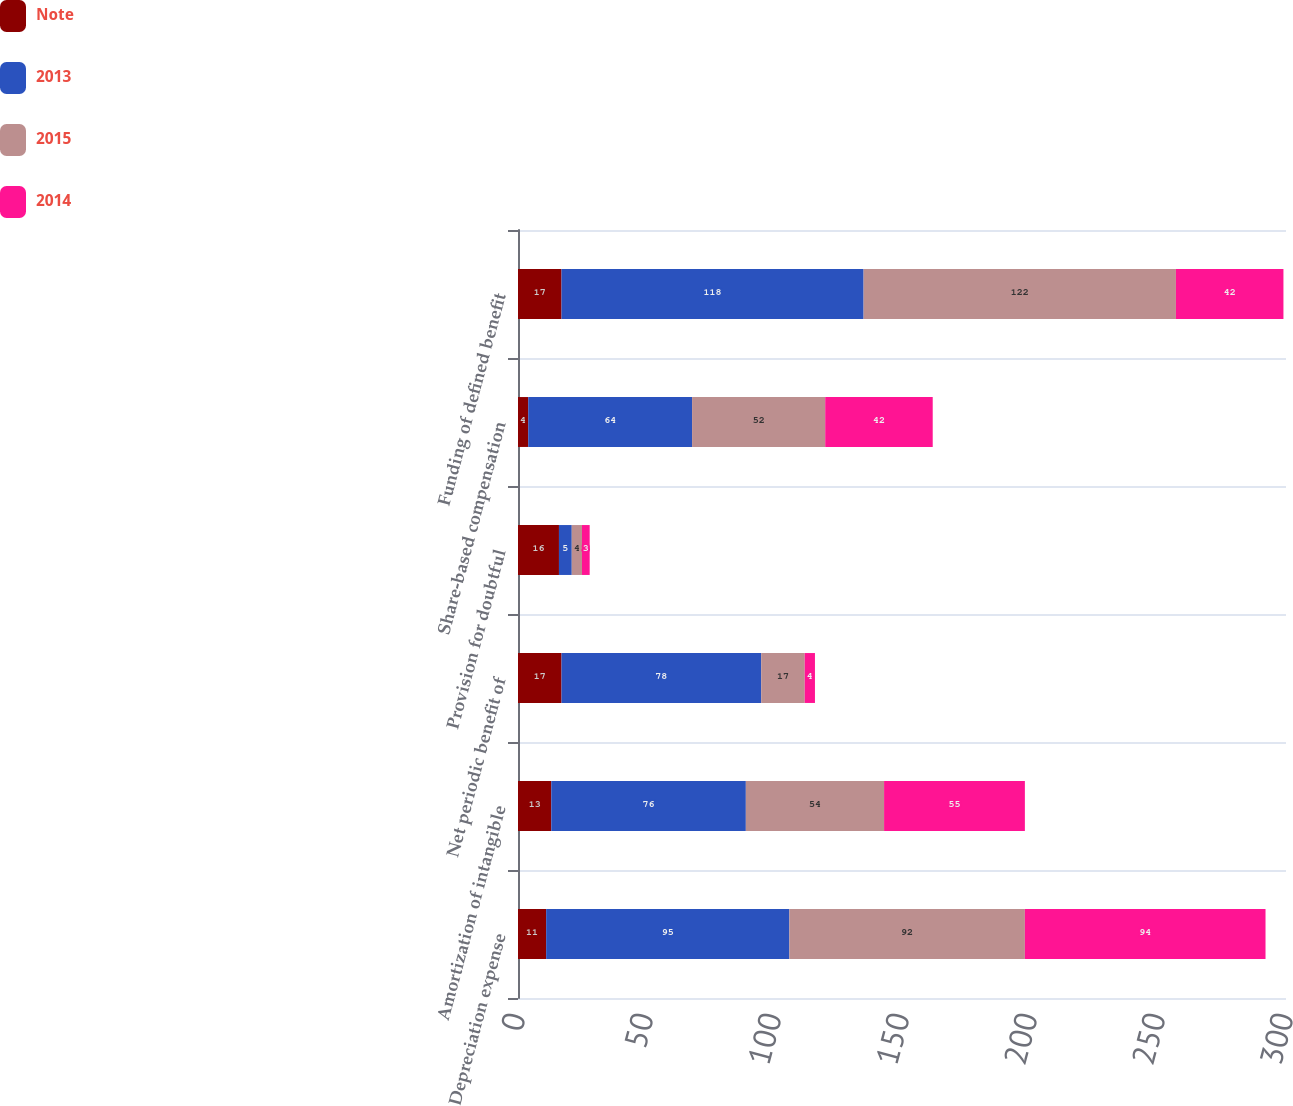Convert chart to OTSL. <chart><loc_0><loc_0><loc_500><loc_500><stacked_bar_chart><ecel><fcel>Depreciation expense<fcel>Amortization of intangible<fcel>Net periodic benefit of<fcel>Provision for doubtful<fcel>Share-based compensation<fcel>Funding of defined benefit<nl><fcel>Note<fcel>11<fcel>13<fcel>17<fcel>16<fcel>4<fcel>17<nl><fcel>2013<fcel>95<fcel>76<fcel>78<fcel>5<fcel>64<fcel>118<nl><fcel>2015<fcel>92<fcel>54<fcel>17<fcel>4<fcel>52<fcel>122<nl><fcel>2014<fcel>94<fcel>55<fcel>4<fcel>3<fcel>42<fcel>42<nl></chart> 